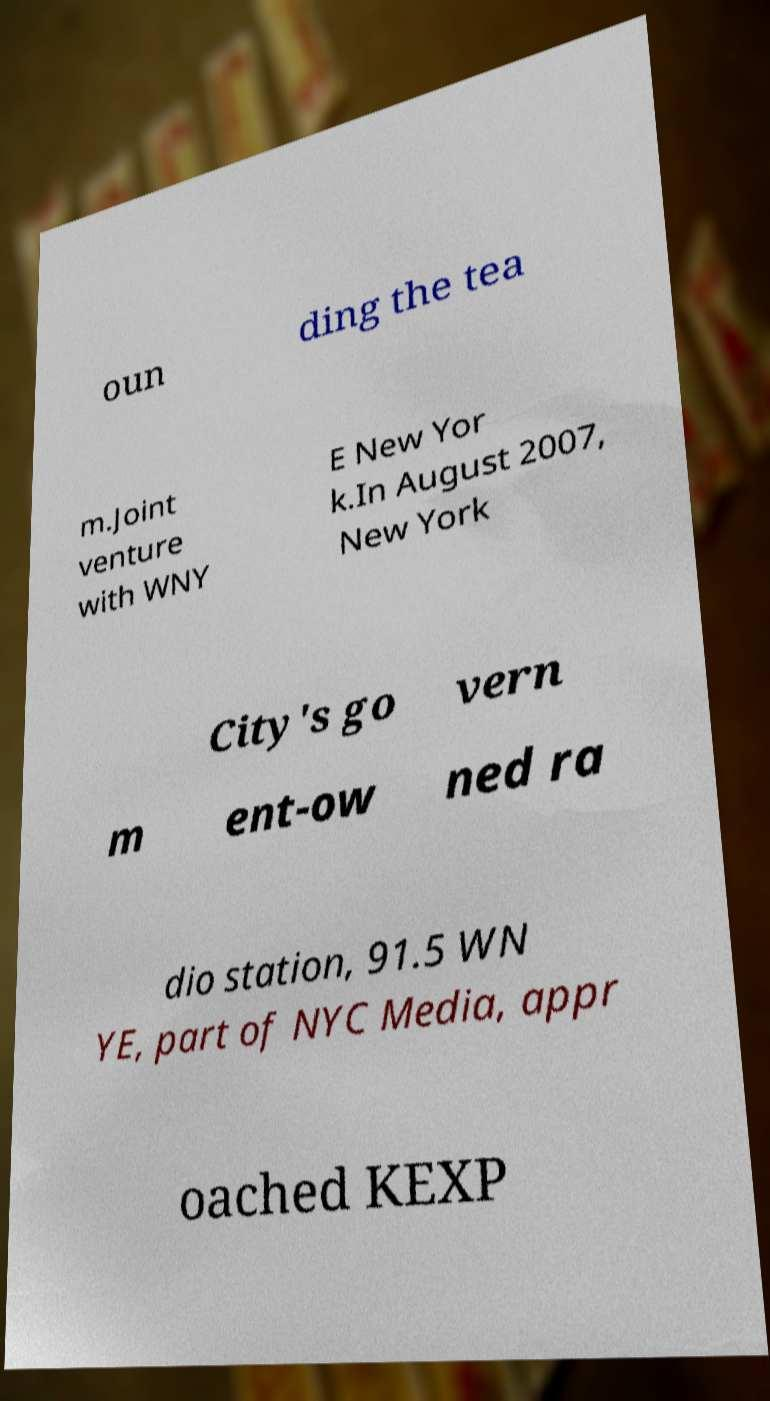There's text embedded in this image that I need extracted. Can you transcribe it verbatim? oun ding the tea m.Joint venture with WNY E New Yor k.In August 2007, New York City's go vern m ent-ow ned ra dio station, 91.5 WN YE, part of NYC Media, appr oached KEXP 